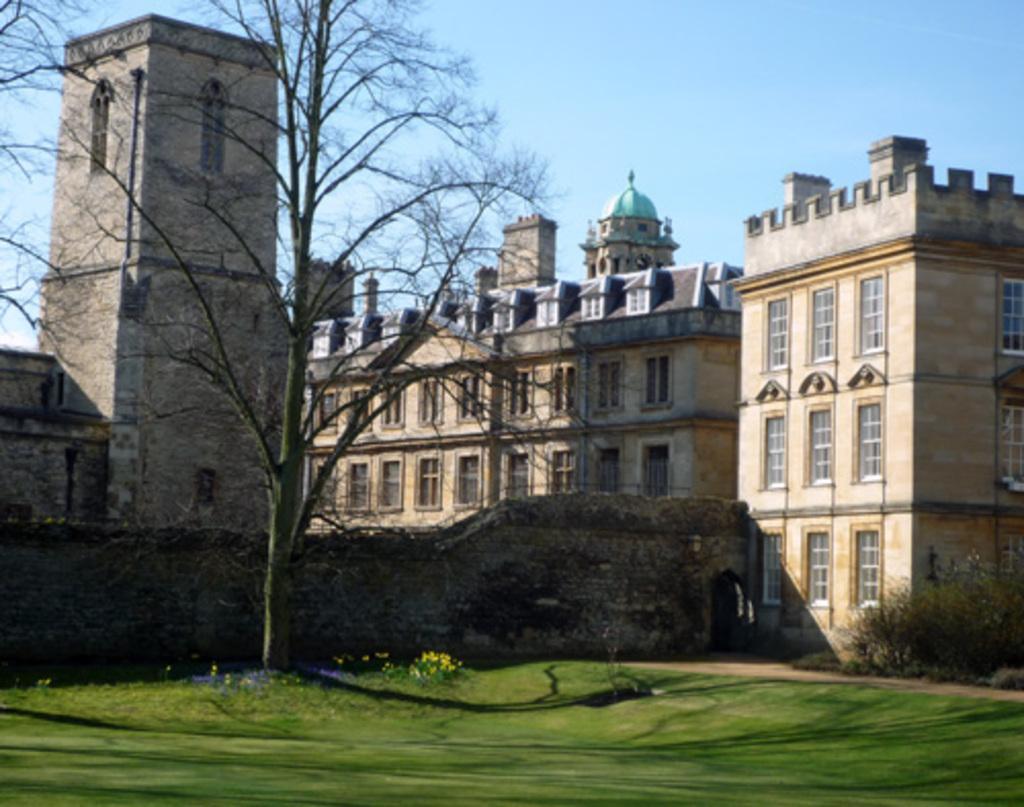Can you describe this image briefly? In this image there is a building, in front of the building there is a tree, in front of the tree there's grass on the surface. 